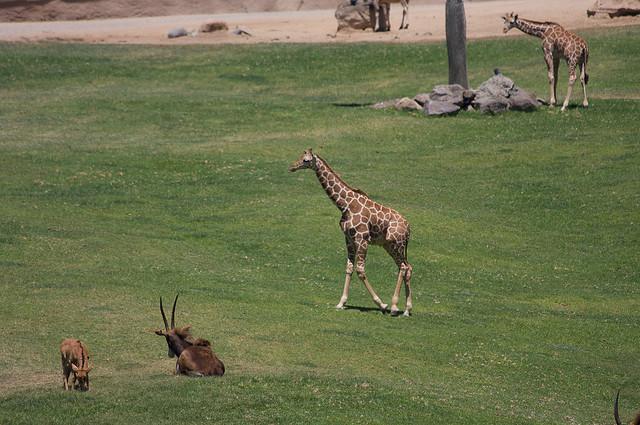Are they wild?
Be succinct. No. How many animals are in this picture?
Write a very short answer. 4. How many animals are in the image?
Give a very brief answer. 4. How many different kinds of animals are visible?
Keep it brief. 2. 